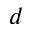Convert formula to latex. <formula><loc_0><loc_0><loc_500><loc_500>d</formula> 